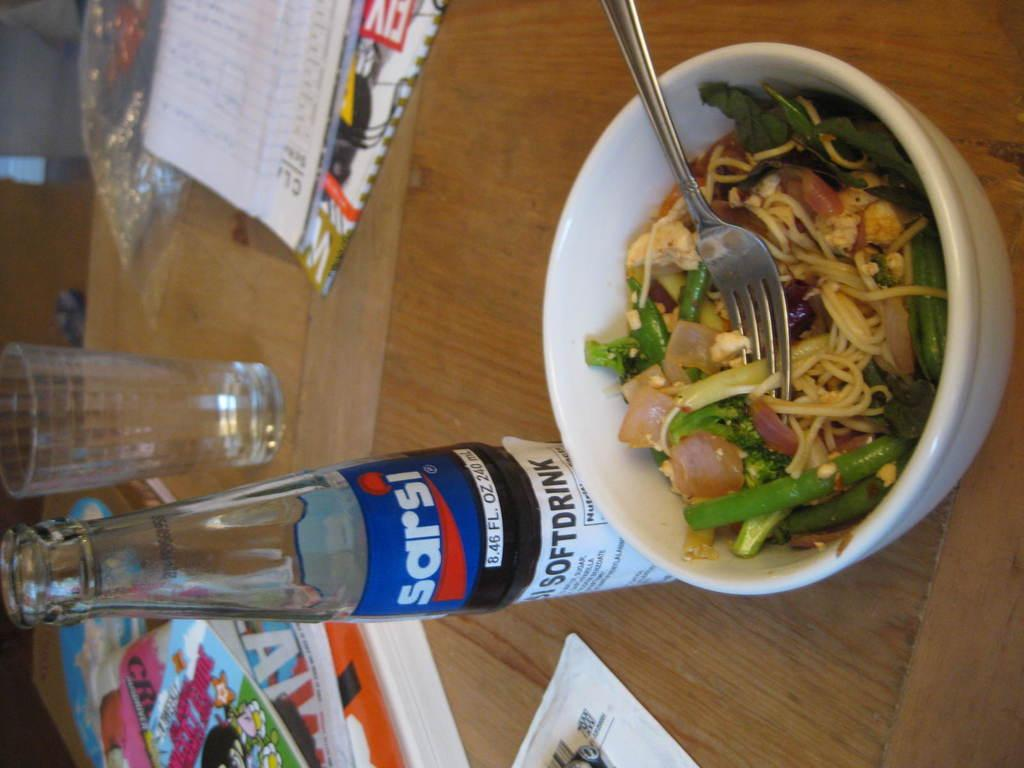Provide a one-sentence caption for the provided image. A bowl with a salad and a half drunk glass bottle of sarsi cola. 